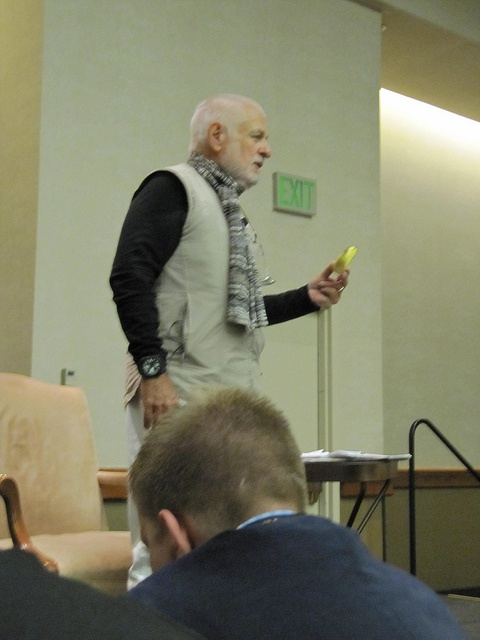Describe the objects in this image and their specific colors. I can see people in tan, black, and gray tones, people in tan, darkgray, black, and gray tones, chair in tan and olive tones, and banana in tan, olive, and khaki tones in this image. 